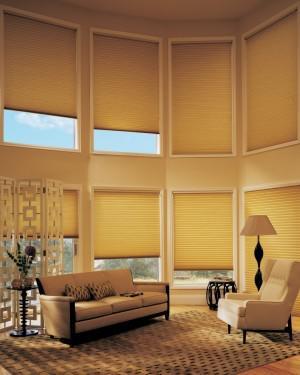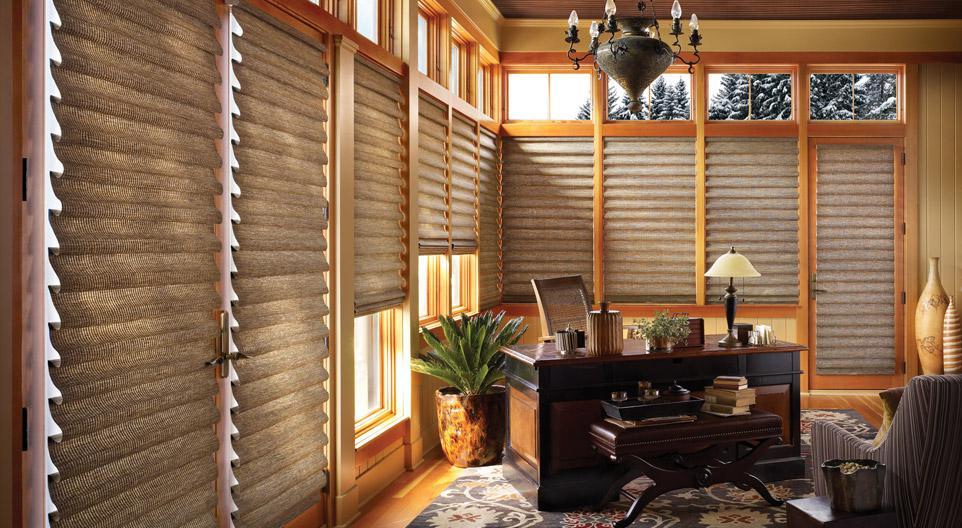The first image is the image on the left, the second image is the image on the right. For the images shown, is this caption "There are eight blinds." true? Answer yes or no. No. The first image is the image on the left, the second image is the image on the right. Examine the images to the left and right. Is the description "There are exactly three shades in the right image." accurate? Answer yes or no. No. 